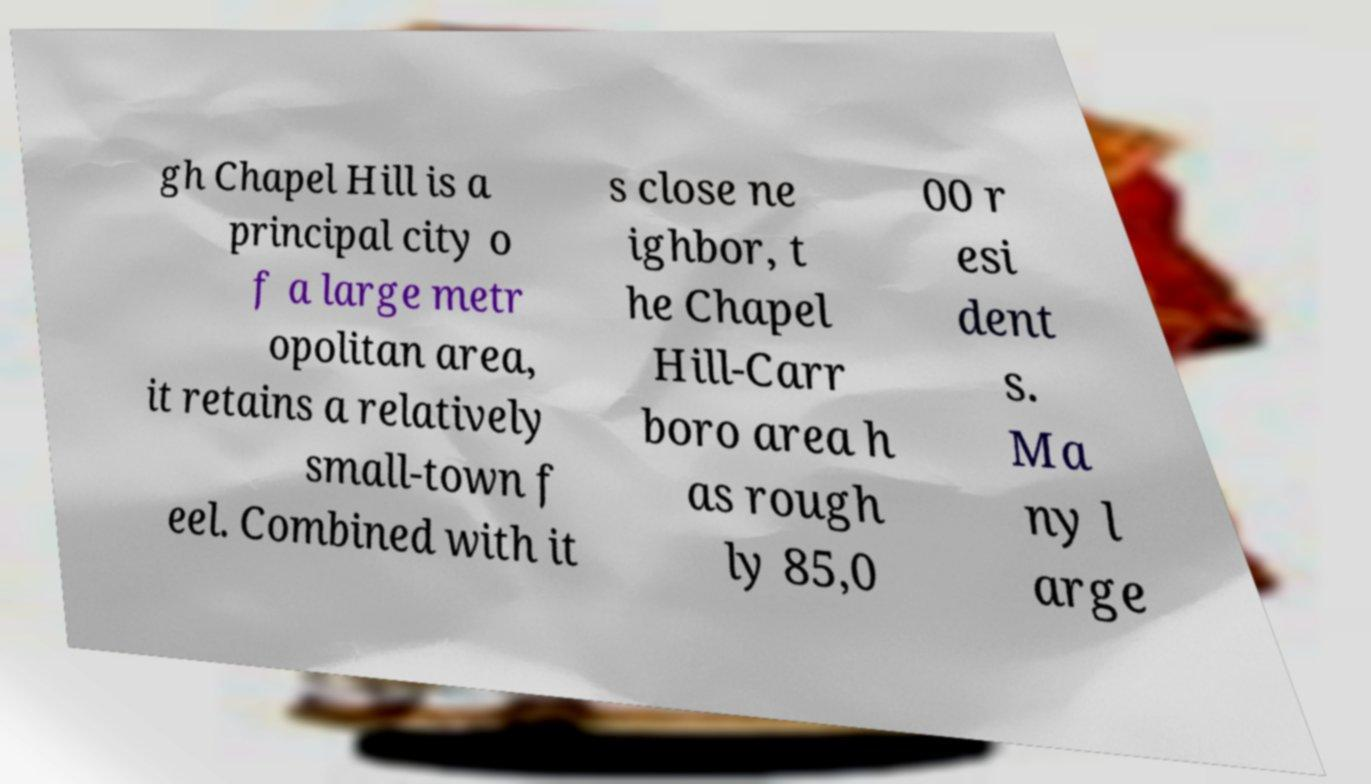Could you extract and type out the text from this image? gh Chapel Hill is a principal city o f a large metr opolitan area, it retains a relatively small-town f eel. Combined with it s close ne ighbor, t he Chapel Hill-Carr boro area h as rough ly 85,0 00 r esi dent s. Ma ny l arge 